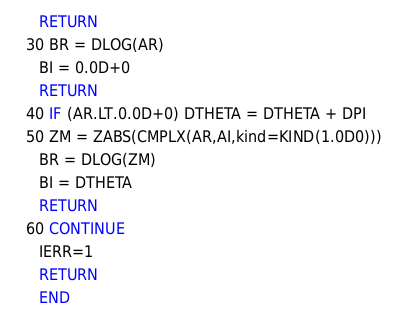Convert code to text. <code><loc_0><loc_0><loc_500><loc_500><_FORTRAN_>      RETURN
   30 BR = DLOG(AR)
      BI = 0.0D+0
      RETURN
   40 IF (AR.LT.0.0D+0) DTHETA = DTHETA + DPI
   50 ZM = ZABS(CMPLX(AR,AI,kind=KIND(1.0D0)))
      BR = DLOG(ZM)
      BI = DTHETA
      RETURN
   60 CONTINUE
      IERR=1
      RETURN
      END
</code> 